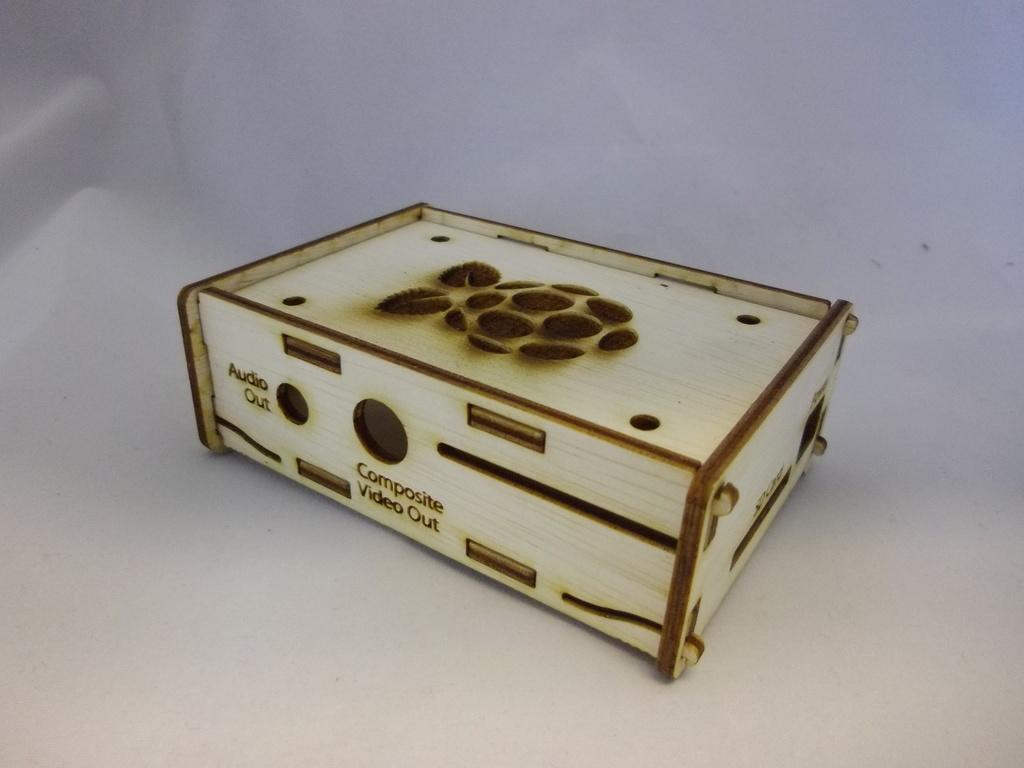<image>
Summarize the visual content of the image. A case for a raspberry pi micro computer that has holes cutout for Audio Out. 